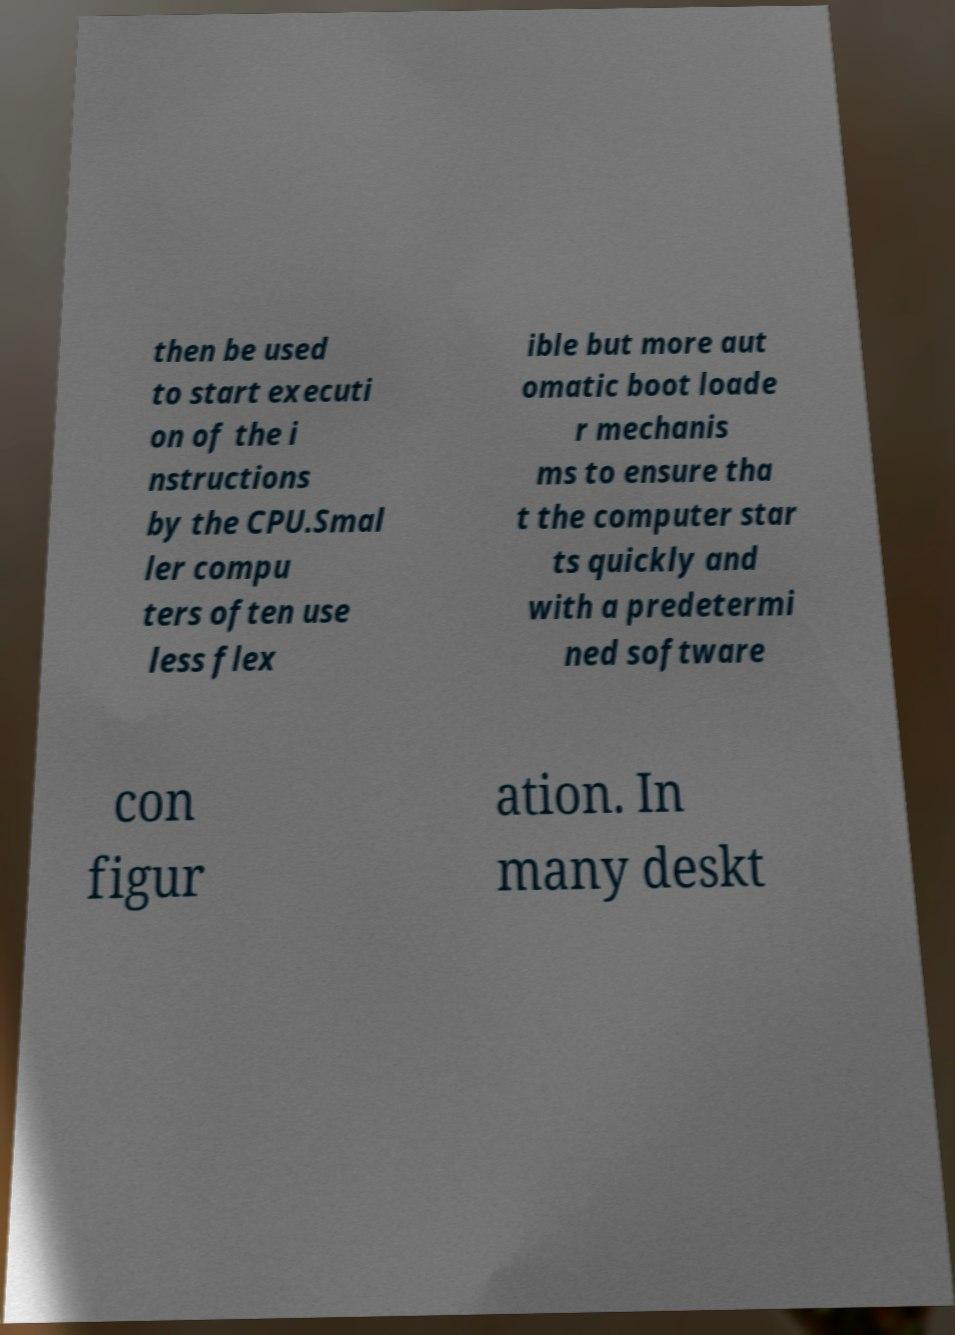I need the written content from this picture converted into text. Can you do that? then be used to start executi on of the i nstructions by the CPU.Smal ler compu ters often use less flex ible but more aut omatic boot loade r mechanis ms to ensure tha t the computer star ts quickly and with a predetermi ned software con figur ation. In many deskt 